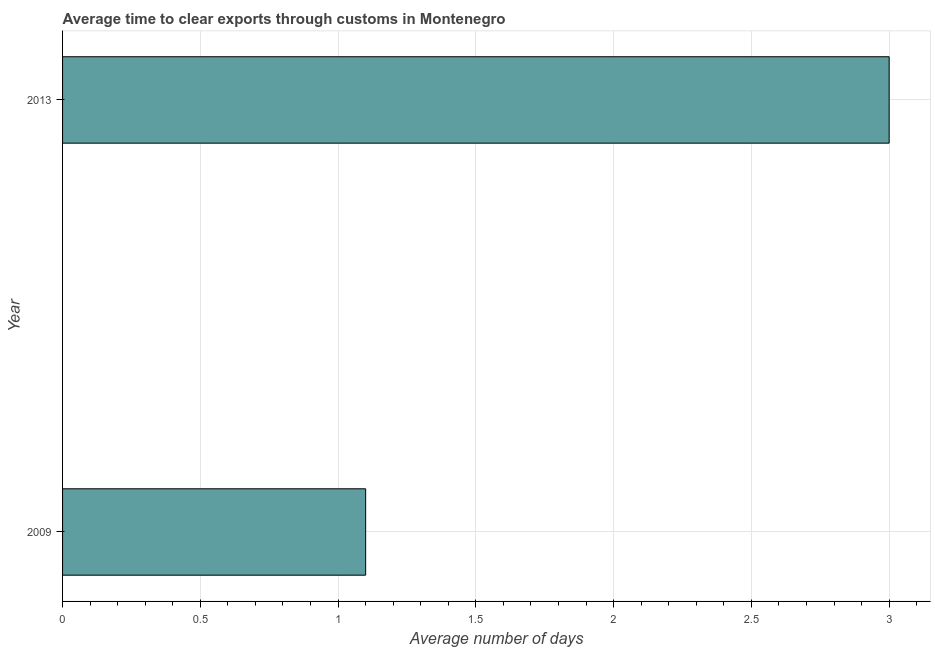What is the title of the graph?
Provide a short and direct response. Average time to clear exports through customs in Montenegro. What is the label or title of the X-axis?
Your answer should be compact. Average number of days. What is the label or title of the Y-axis?
Offer a very short reply. Year. Across all years, what is the maximum time to clear exports through customs?
Give a very brief answer. 3. Across all years, what is the minimum time to clear exports through customs?
Make the answer very short. 1.1. What is the average time to clear exports through customs per year?
Provide a short and direct response. 2.05. What is the median time to clear exports through customs?
Provide a short and direct response. 2.05. What is the ratio of the time to clear exports through customs in 2009 to that in 2013?
Provide a short and direct response. 0.37. In how many years, is the time to clear exports through customs greater than the average time to clear exports through customs taken over all years?
Offer a very short reply. 1. Are all the bars in the graph horizontal?
Keep it short and to the point. Yes. What is the Average number of days of 2013?
Give a very brief answer. 3. What is the difference between the Average number of days in 2009 and 2013?
Offer a terse response. -1.9. What is the ratio of the Average number of days in 2009 to that in 2013?
Ensure brevity in your answer.  0.37. 